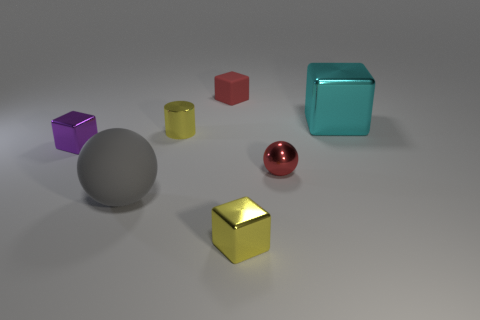How many purple objects are either matte spheres or small matte cubes?
Offer a terse response. 0. What number of things are either yellow things or matte things in front of the purple shiny cube?
Keep it short and to the point. 3. What is the small yellow thing that is in front of the gray thing made of?
Ensure brevity in your answer.  Metal. What shape is the red metal thing that is the same size as the purple shiny cube?
Your response must be concise. Sphere. Is there a big red metal object of the same shape as the large cyan thing?
Provide a succinct answer. No. Is the tiny sphere made of the same material as the large object that is to the left of the small red block?
Your response must be concise. No. There is a purple block that is left of the red thing that is in front of the big metal object; what is it made of?
Your response must be concise. Metal. Is the number of yellow metallic things in front of the large gray rubber sphere greater than the number of tiny purple rubber things?
Your response must be concise. Yes. Are there any metallic spheres?
Ensure brevity in your answer.  Yes. The small object in front of the big ball is what color?
Make the answer very short. Yellow. 